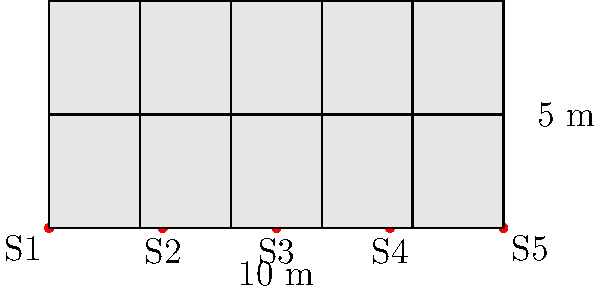As a music producer collaborating on unique food and music experiences, you're working on a restaurant project that requires a suspended acoustic ceiling. The ceiling area is 10 m x 5 m, with five equally spaced suspension points along the 10 m side. Each acoustic panel weighs 15 kg/m², and the total load capacity of each suspension point is 250 kg. What is the maximum additional load (in kg/m²) that can be safely added to the ceiling for lighting and other equipment while maintaining a safety factor of 1.5? Let's approach this step-by-step:

1. Calculate the total ceiling area:
   Area = 10 m × 5 m = 50 m²

2. Calculate the weight of the acoustic panels:
   Panel weight = 15 kg/m² × 50 m² = 750 kg

3. Calculate the total load capacity of all suspension points:
   Total capacity = 250 kg × 5 points = 1250 kg

4. Apply the safety factor:
   Safe load capacity = 1250 kg ÷ 1.5 = 833.33 kg

5. Calculate the remaining capacity for additional load:
   Remaining capacity = 833.33 kg - 750 kg = 83.33 kg

6. Convert the remaining capacity to kg/m²:
   Additional load capacity = 83.33 kg ÷ 50 m² = 1.67 kg/m²

Therefore, the maximum additional load that can be safely added to the ceiling is 1.67 kg/m².
Answer: 1.67 kg/m² 